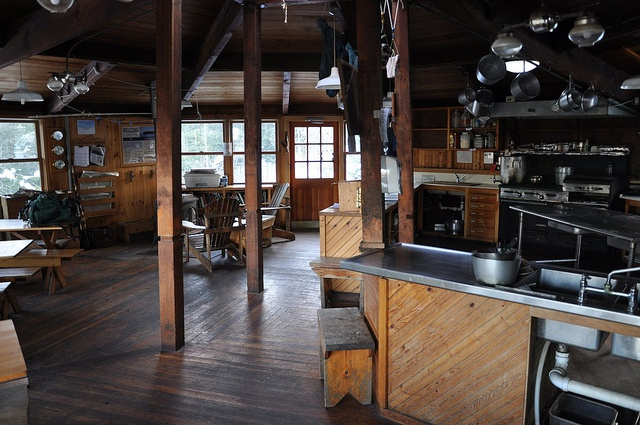Describe the objects in this image and their specific colors. I can see bench in black, gray, brown, and maroon tones, dining table in black, gray, and darkgray tones, chair in black, gray, and maroon tones, sink in black, darkgray, and gray tones, and backpack in black, teal, gray, and darkblue tones in this image. 